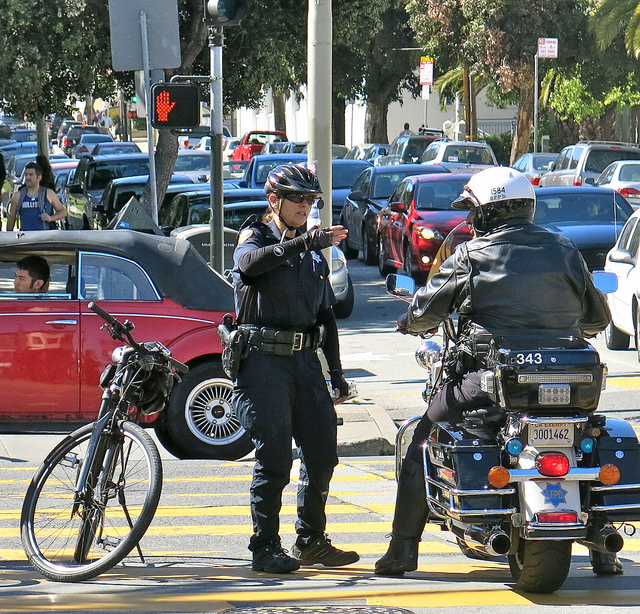What could be a reason for the officer's hand gesture? The officer's hand gesture, with one hand extended outward, could be an indication of direction or distance. It's a common way to point out specific areas or routes during a discussion, especially in scenarios concerning traffic control, accident management, or patrol area division among officers. 